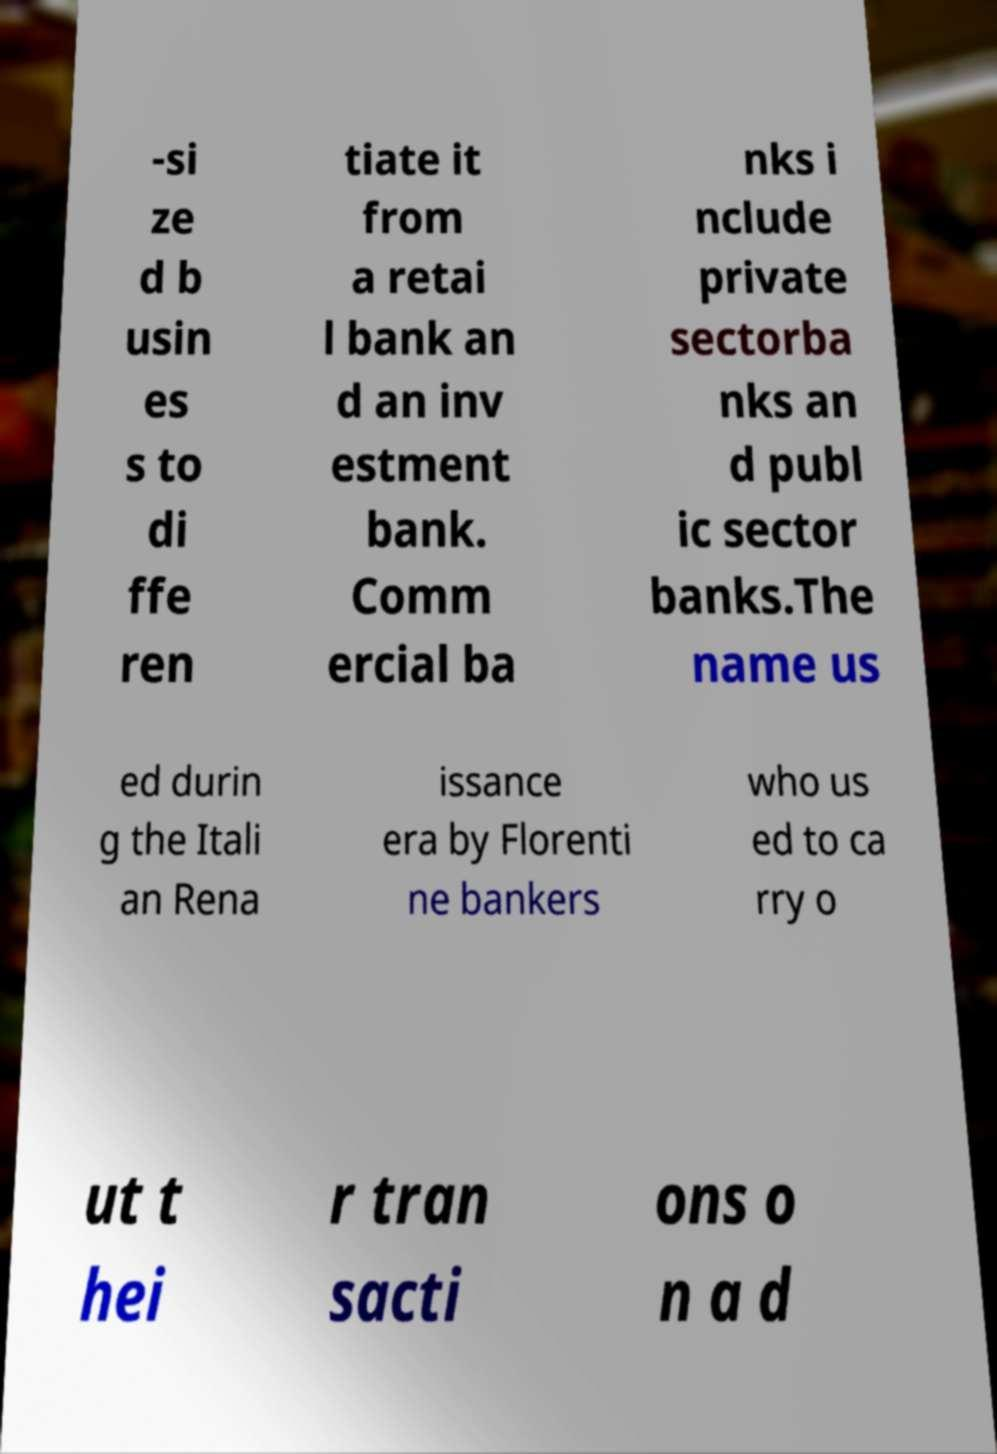Please identify and transcribe the text found in this image. -si ze d b usin es s to di ffe ren tiate it from a retai l bank an d an inv estment bank. Comm ercial ba nks i nclude private sectorba nks an d publ ic sector banks.The name us ed durin g the Itali an Rena issance era by Florenti ne bankers who us ed to ca rry o ut t hei r tran sacti ons o n a d 